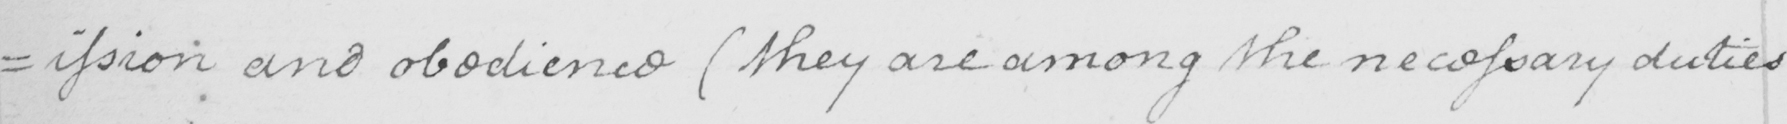Can you tell me what this handwritten text says? =ission and obedience  ( they are among the necessary duties 